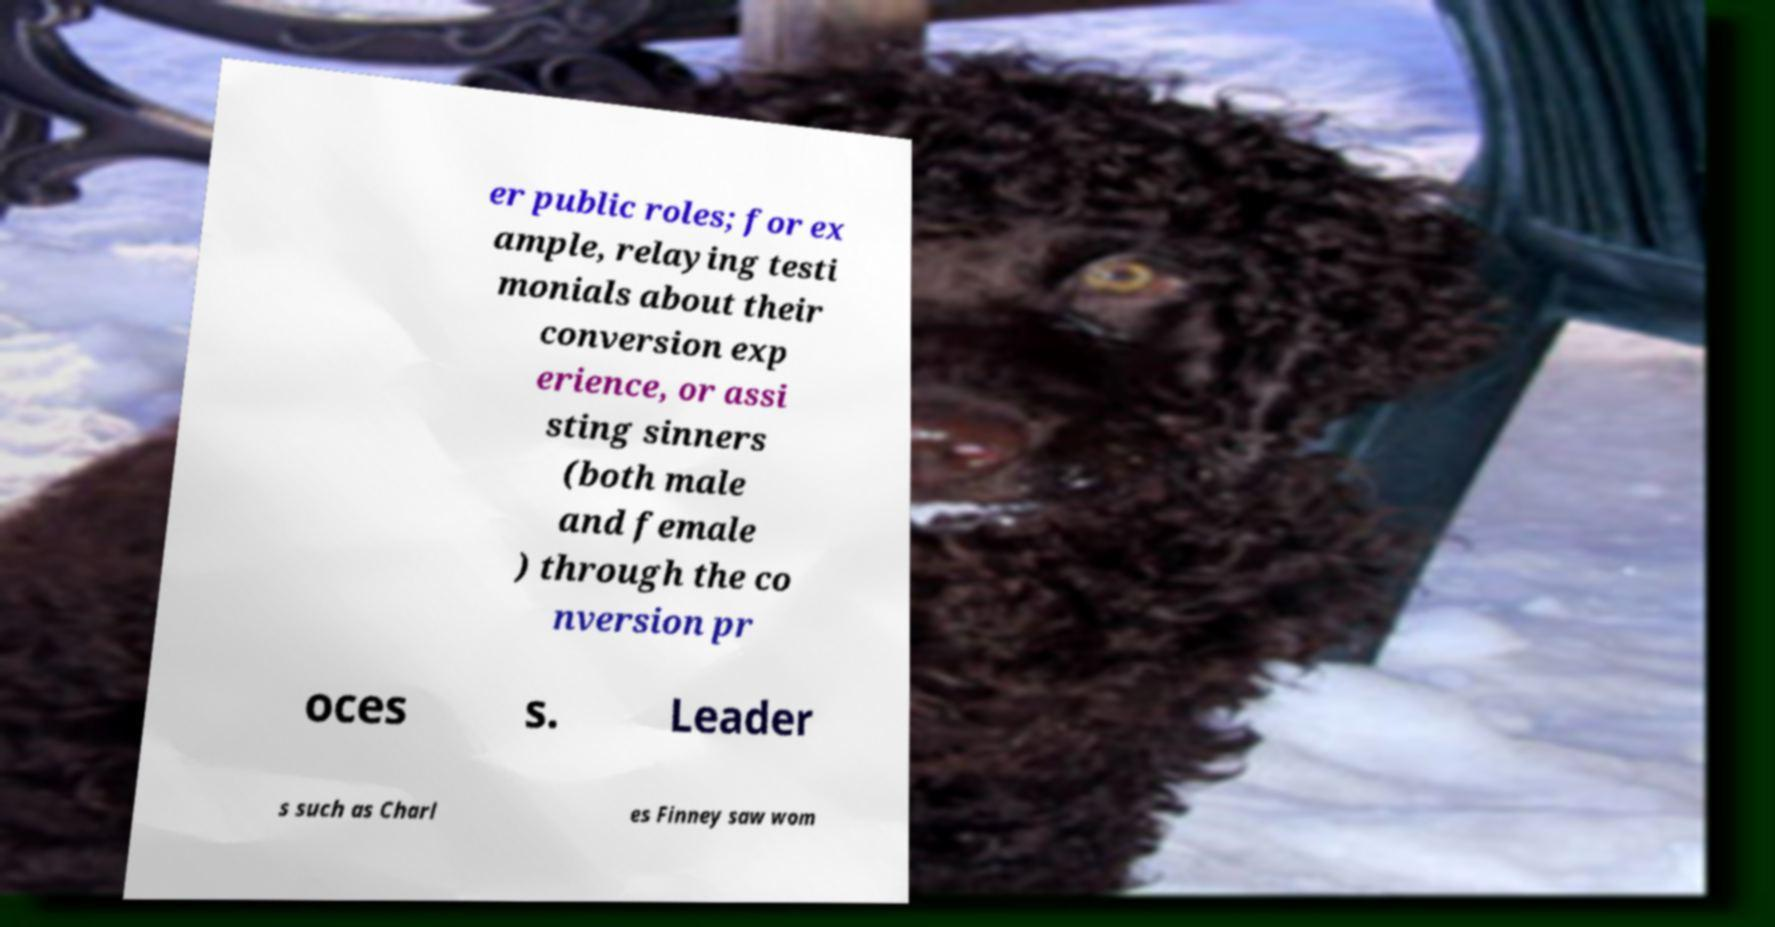For documentation purposes, I need the text within this image transcribed. Could you provide that? er public roles; for ex ample, relaying testi monials about their conversion exp erience, or assi sting sinners (both male and female ) through the co nversion pr oces s. Leader s such as Charl es Finney saw wom 